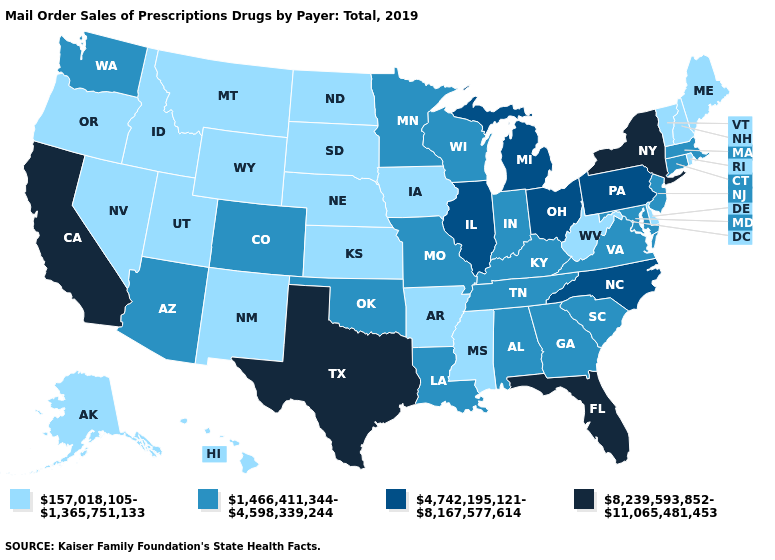Among the states that border Georgia , does North Carolina have the lowest value?
Short answer required. No. Does Ohio have the lowest value in the MidWest?
Keep it brief. No. What is the value of Illinois?
Quick response, please. 4,742,195,121-8,167,577,614. Is the legend a continuous bar?
Give a very brief answer. No. Which states hav the highest value in the West?
Be succinct. California. Name the states that have a value in the range 1,466,411,344-4,598,339,244?
Concise answer only. Alabama, Arizona, Colorado, Connecticut, Georgia, Indiana, Kentucky, Louisiana, Maryland, Massachusetts, Minnesota, Missouri, New Jersey, Oklahoma, South Carolina, Tennessee, Virginia, Washington, Wisconsin. What is the value of North Dakota?
Short answer required. 157,018,105-1,365,751,133. What is the value of Maine?
Give a very brief answer. 157,018,105-1,365,751,133. Name the states that have a value in the range 157,018,105-1,365,751,133?
Concise answer only. Alaska, Arkansas, Delaware, Hawaii, Idaho, Iowa, Kansas, Maine, Mississippi, Montana, Nebraska, Nevada, New Hampshire, New Mexico, North Dakota, Oregon, Rhode Island, South Dakota, Utah, Vermont, West Virginia, Wyoming. Which states have the highest value in the USA?
Concise answer only. California, Florida, New York, Texas. Does Michigan have a higher value than Montana?
Be succinct. Yes. Which states have the lowest value in the South?
Quick response, please. Arkansas, Delaware, Mississippi, West Virginia. Name the states that have a value in the range 1,466,411,344-4,598,339,244?
Keep it brief. Alabama, Arizona, Colorado, Connecticut, Georgia, Indiana, Kentucky, Louisiana, Maryland, Massachusetts, Minnesota, Missouri, New Jersey, Oklahoma, South Carolina, Tennessee, Virginia, Washington, Wisconsin. Among the states that border Delaware , does Pennsylvania have the lowest value?
Give a very brief answer. No. Name the states that have a value in the range 8,239,593,852-11,065,481,453?
Write a very short answer. California, Florida, New York, Texas. 